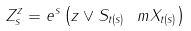Convert formula to latex. <formula><loc_0><loc_0><loc_500><loc_500>Z _ { s } ^ { z } = e ^ { s } \left ( z \vee S _ { t ( s ) } \ m X _ { t ( s ) } \right )</formula> 